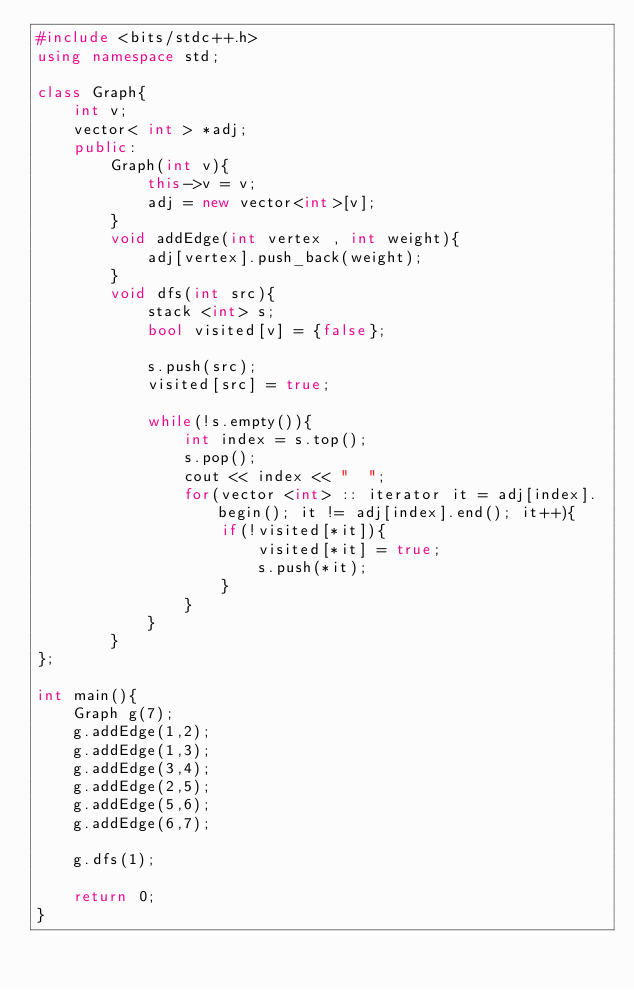<code> <loc_0><loc_0><loc_500><loc_500><_C++_>#include <bits/stdc++.h>
using namespace std;

class Graph{
    int v;
    vector< int > *adj;
    public:
        Graph(int v){
            this->v = v;
            adj = new vector<int>[v];
        }
        void addEdge(int vertex , int weight){
            adj[vertex].push_back(weight);
        }
        void dfs(int src){
            stack <int> s;
            bool visited[v] = {false};
            
            s.push(src);
            visited[src] = true;

            while(!s.empty()){
                int index = s.top();
                s.pop();
                cout << index << "  ";
                for(vector <int> :: iterator it = adj[index].begin(); it != adj[index].end(); it++){
                    if(!visited[*it]){
                        visited[*it] = true;
                        s.push(*it);
                    }
                }
            } 
        }
};

int main(){
    Graph g(7);
    g.addEdge(1,2);
    g.addEdge(1,3);
    g.addEdge(3,4);
    g.addEdge(2,5);
    g.addEdge(5,6);
    g.addEdge(6,7);
    
    g.dfs(1);

    return 0;
}</code> 